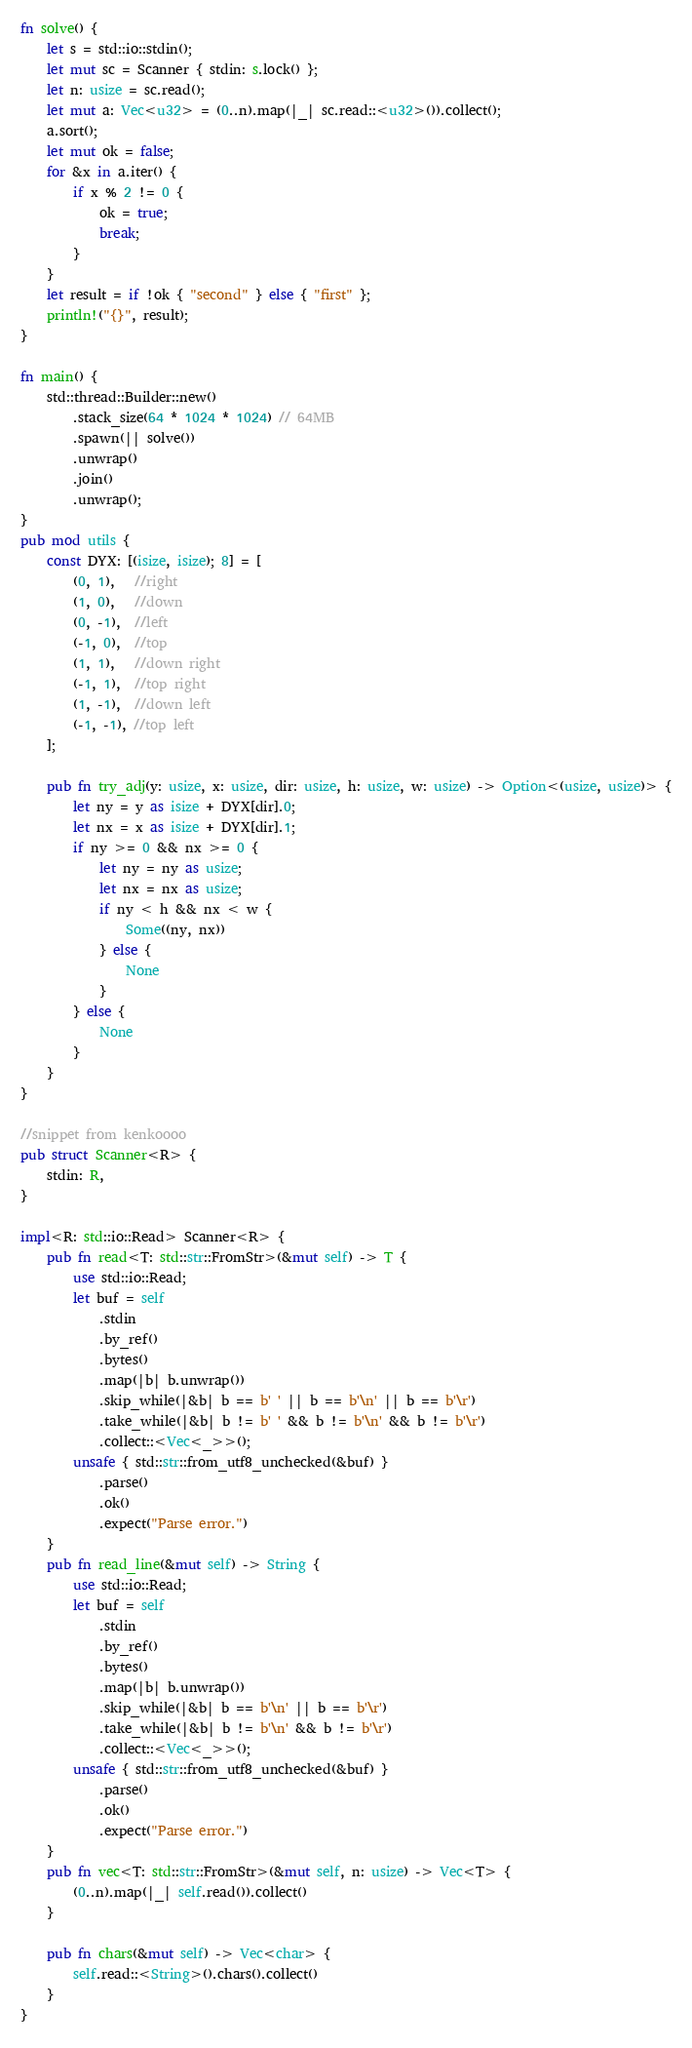Convert code to text. <code><loc_0><loc_0><loc_500><loc_500><_Rust_>fn solve() {
    let s = std::io::stdin();
    let mut sc = Scanner { stdin: s.lock() };
    let n: usize = sc.read();
    let mut a: Vec<u32> = (0..n).map(|_| sc.read::<u32>()).collect();
    a.sort();
    let mut ok = false;
    for &x in a.iter() {
        if x % 2 != 0 {
            ok = true;
            break;
        }
    }
    let result = if !ok { "second" } else { "first" };
    println!("{}", result);
}

fn main() {
    std::thread::Builder::new()
        .stack_size(64 * 1024 * 1024) // 64MB
        .spawn(|| solve())
        .unwrap()
        .join()
        .unwrap();
}
pub mod utils {
    const DYX: [(isize, isize); 8] = [
        (0, 1),   //right
        (1, 0),   //down
        (0, -1),  //left
        (-1, 0),  //top
        (1, 1),   //down right
        (-1, 1),  //top right
        (1, -1),  //down left
        (-1, -1), //top left
    ];

    pub fn try_adj(y: usize, x: usize, dir: usize, h: usize, w: usize) -> Option<(usize, usize)> {
        let ny = y as isize + DYX[dir].0;
        let nx = x as isize + DYX[dir].1;
        if ny >= 0 && nx >= 0 {
            let ny = ny as usize;
            let nx = nx as usize;
            if ny < h && nx < w {
                Some((ny, nx))
            } else {
                None
            }
        } else {
            None
        }
    }
}

//snippet from kenkoooo
pub struct Scanner<R> {
    stdin: R,
}

impl<R: std::io::Read> Scanner<R> {
    pub fn read<T: std::str::FromStr>(&mut self) -> T {
        use std::io::Read;
        let buf = self
            .stdin
            .by_ref()
            .bytes()
            .map(|b| b.unwrap())
            .skip_while(|&b| b == b' ' || b == b'\n' || b == b'\r')
            .take_while(|&b| b != b' ' && b != b'\n' && b != b'\r')
            .collect::<Vec<_>>();
        unsafe { std::str::from_utf8_unchecked(&buf) }
            .parse()
            .ok()
            .expect("Parse error.")
    }
    pub fn read_line(&mut self) -> String {
        use std::io::Read;
        let buf = self
            .stdin
            .by_ref()
            .bytes()
            .map(|b| b.unwrap())
            .skip_while(|&b| b == b'\n' || b == b'\r')
            .take_while(|&b| b != b'\n' && b != b'\r')
            .collect::<Vec<_>>();
        unsafe { std::str::from_utf8_unchecked(&buf) }
            .parse()
            .ok()
            .expect("Parse error.")
    }
    pub fn vec<T: std::str::FromStr>(&mut self, n: usize) -> Vec<T> {
        (0..n).map(|_| self.read()).collect()
    }

    pub fn chars(&mut self) -> Vec<char> {
        self.read::<String>().chars().collect()
    }
}
</code> 